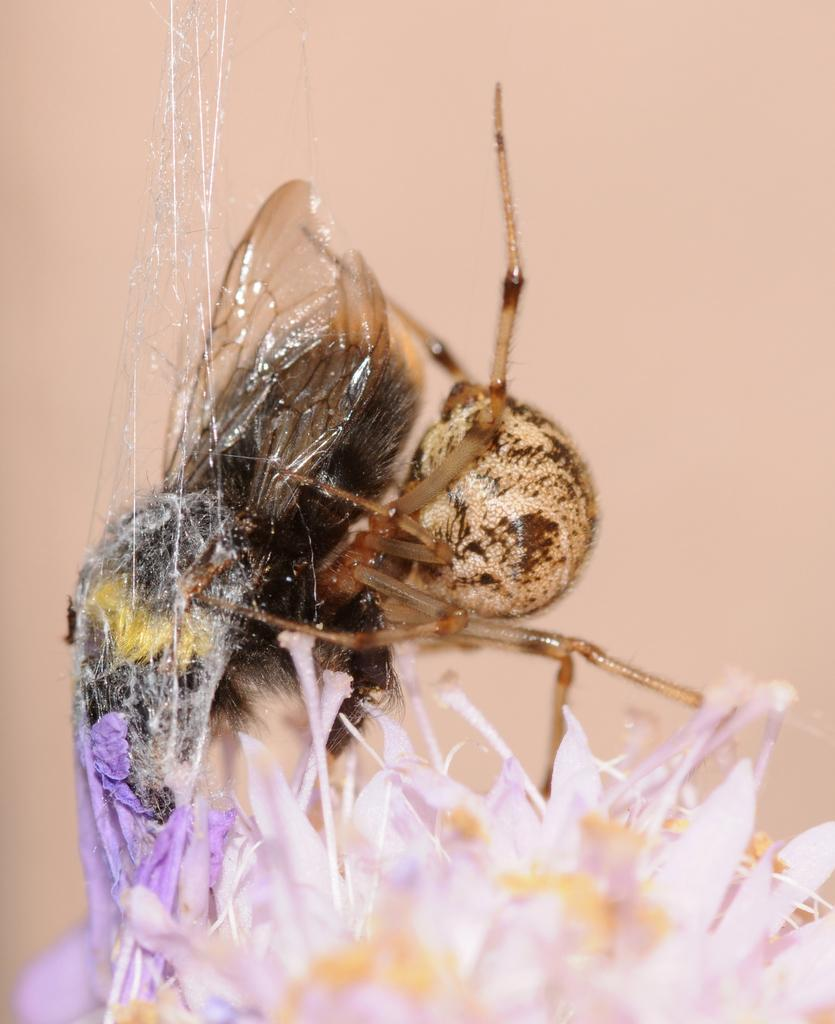What type of plant can be seen in the image? There is a flower in the image. What color is the flower? The flower is in violet color. Are there any animals present in the image? Yes, there is a bee in the image. What color is the bee? The bee is in brown color. What type of stocking is the parent wearing in the image? There is no parent or stocking present in the image; it only features a flower and a bee. 